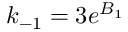<formula> <loc_0><loc_0><loc_500><loc_500>k _ { - 1 } = 3 e ^ { B _ { 1 } }</formula> 